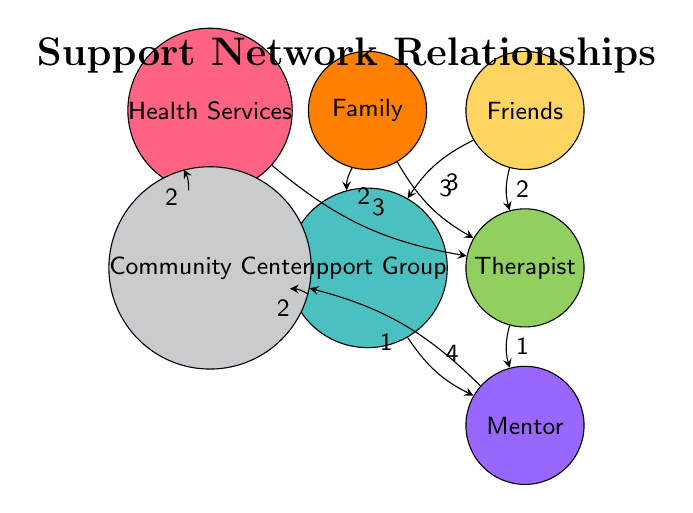What's the total number of nodes in the diagram? The nodes listed are Family, Friends, Therapist, Support Group, Mentor, Health Services, and Community Center. Counting these gives a total of 7 nodes.
Answer: 7 What is the value of the relationship between Friends and Support Group? The link from Friends to Support Group shows a value of 3, indicating the strength of this relationship.
Answer: 3 How many connections does the Support Group have? The Support Group connects to three nodes: Family, Friends, and Mentor, as well as having a connection from the Community Center. Counting these provides a total of 4 connections.
Answer: 4 Which node has the highest value connection to Mentor? The connection from Support Group to Mentor has the highest value of 4, compared to the other connections.
Answer: Support Group What is the value of the relationship between Health Services and Therapist? The link from Health Services to Therapist indicates a value of 3, representing the strength of their relationship.
Answer: 3 Which node does Family have the strongest relationship with? The relationship from Family to Support Group has a value of 2 while its relationship to Therapist is stronger at 3. Therefore, the strongest relationship for Family is with Therapist, at a value of 3.
Answer: Therapist What is the lowest value connection in the diagram? The connection from Therapist to Mentor has the lowest value of 1, indicating a weaker relationship compared to others.
Answer: 1 What role does Community Center play in the network? The Community Center connects to Health Services and Support Group, acting as a resource for support and connection to other services, particularly through its link to Support Group with a value of 2.
Answer: Resource How do Family and Friends connect to Therapist? Family has a direct connection to Therapist with a value of 3, and Friends also connect to Therapist with a value of 2, showing that both Family and Friends support the individual in accessing professional help.
Answer: Connections through Family (3) and Friends (2) 